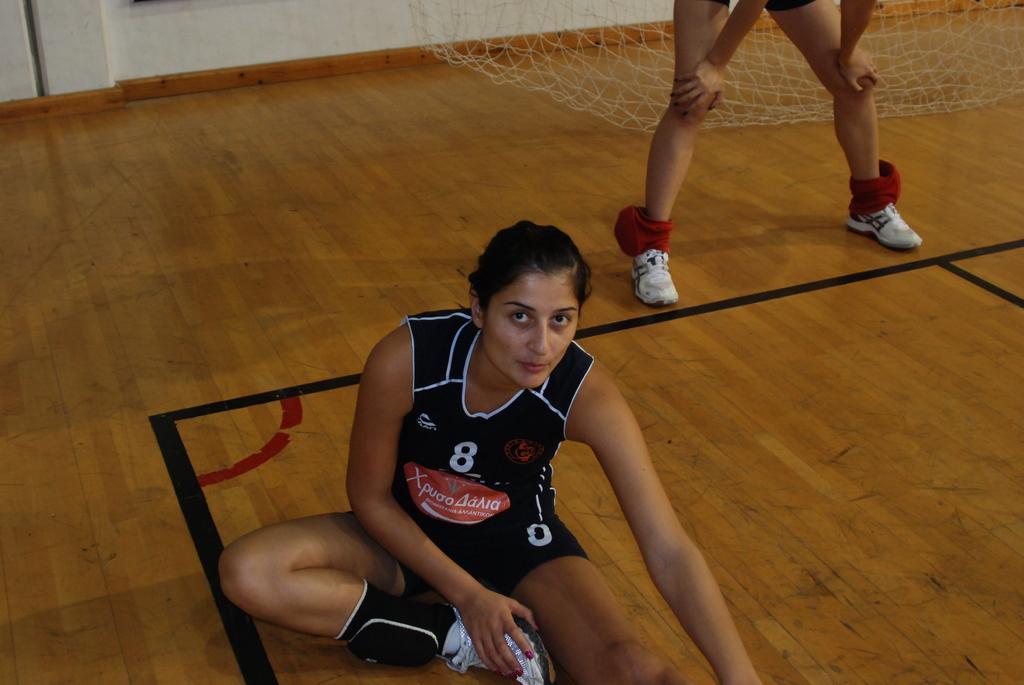Please provide a concise description of this image. In this image in the front there is a woman sitting on the floor. In the background there is a person standing and there is a net which is white in colour. 